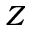<formula> <loc_0><loc_0><loc_500><loc_500>Z</formula> 